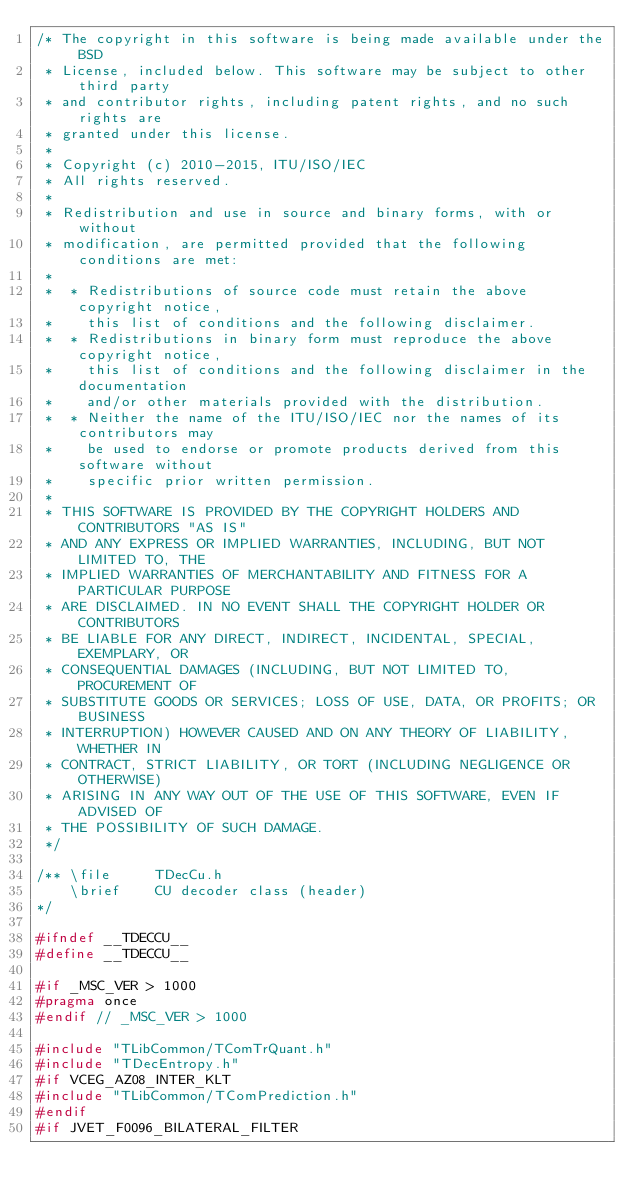<code> <loc_0><loc_0><loc_500><loc_500><_C_>/* The copyright in this software is being made available under the BSD
 * License, included below. This software may be subject to other third party
 * and contributor rights, including patent rights, and no such rights are
 * granted under this license.
 *
 * Copyright (c) 2010-2015, ITU/ISO/IEC
 * All rights reserved.
 *
 * Redistribution and use in source and binary forms, with or without
 * modification, are permitted provided that the following conditions are met:
 *
 *  * Redistributions of source code must retain the above copyright notice,
 *    this list of conditions and the following disclaimer.
 *  * Redistributions in binary form must reproduce the above copyright notice,
 *    this list of conditions and the following disclaimer in the documentation
 *    and/or other materials provided with the distribution.
 *  * Neither the name of the ITU/ISO/IEC nor the names of its contributors may
 *    be used to endorse or promote products derived from this software without
 *    specific prior written permission.
 *
 * THIS SOFTWARE IS PROVIDED BY THE COPYRIGHT HOLDERS AND CONTRIBUTORS "AS IS"
 * AND ANY EXPRESS OR IMPLIED WARRANTIES, INCLUDING, BUT NOT LIMITED TO, THE
 * IMPLIED WARRANTIES OF MERCHANTABILITY AND FITNESS FOR A PARTICULAR PURPOSE
 * ARE DISCLAIMED. IN NO EVENT SHALL THE COPYRIGHT HOLDER OR CONTRIBUTORS
 * BE LIABLE FOR ANY DIRECT, INDIRECT, INCIDENTAL, SPECIAL, EXEMPLARY, OR
 * CONSEQUENTIAL DAMAGES (INCLUDING, BUT NOT LIMITED TO, PROCUREMENT OF
 * SUBSTITUTE GOODS OR SERVICES; LOSS OF USE, DATA, OR PROFITS; OR BUSINESS
 * INTERRUPTION) HOWEVER CAUSED AND ON ANY THEORY OF LIABILITY, WHETHER IN
 * CONTRACT, STRICT LIABILITY, OR TORT (INCLUDING NEGLIGENCE OR OTHERWISE)
 * ARISING IN ANY WAY OUT OF THE USE OF THIS SOFTWARE, EVEN IF ADVISED OF
 * THE POSSIBILITY OF SUCH DAMAGE.
 */

/** \file     TDecCu.h
    \brief    CU decoder class (header)
*/

#ifndef __TDECCU__
#define __TDECCU__

#if _MSC_VER > 1000
#pragma once
#endif // _MSC_VER > 1000

#include "TLibCommon/TComTrQuant.h"
#include "TDecEntropy.h"
#if VCEG_AZ08_INTER_KLT
#include "TLibCommon/TComPrediction.h"
#endif
#if JVET_F0096_BILATERAL_FILTER</code> 